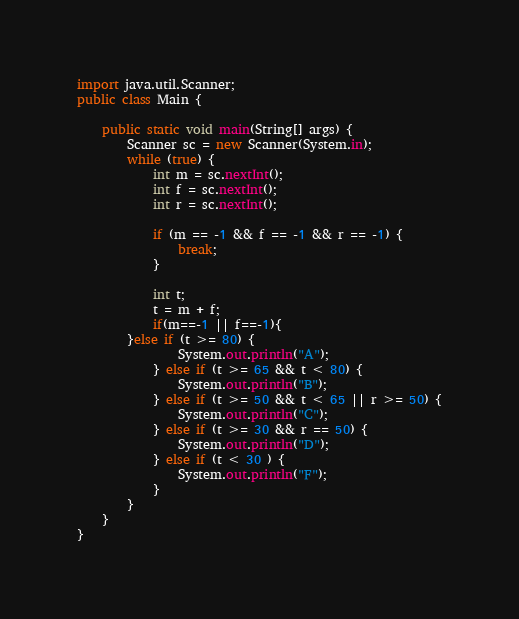Convert code to text. <code><loc_0><loc_0><loc_500><loc_500><_Java_>import java.util.Scanner;
public class Main {

    public static void main(String[] args) {
        Scanner sc = new Scanner(System.in);
        while (true) {
            int m = sc.nextInt();
            int f = sc.nextInt();
            int r = sc.nextInt();

            if (m == -1 && f == -1 && r == -1) {
                break;
            }

            int t;
            t = m + f;
            if(m==-1 || f==-1){
        }else if (t >= 80) {
                System.out.println("A");
            } else if (t >= 65 && t < 80) {
                System.out.println("B");
            } else if (t >= 50 && t < 65 || r >= 50) {
                System.out.println("C");
            } else if (t >= 30 && r == 50) {
                System.out.println("D");
            } else if (t < 30 ) {
                System.out.println("F");
            }
        }
    }
}

</code> 